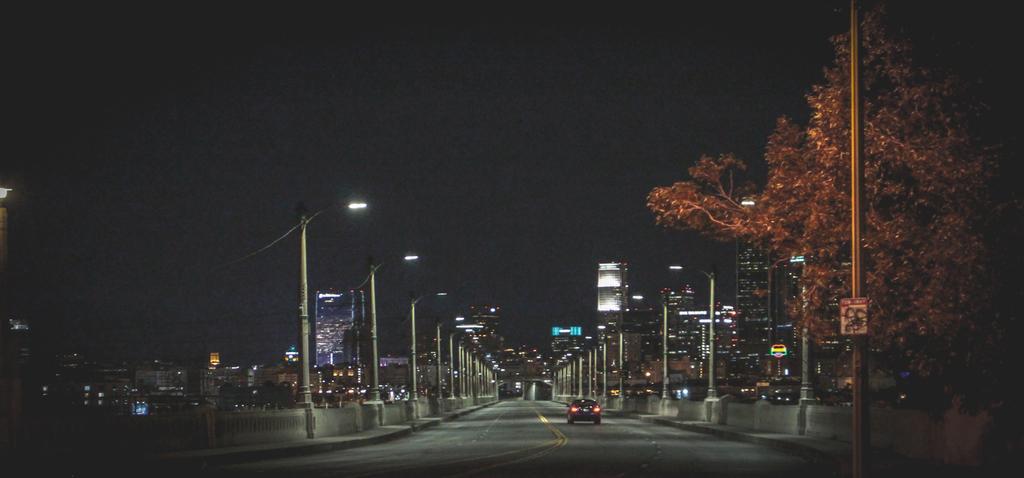Can you describe this image briefly? Vehicle is on the road. Beside this road there are light poles. Far there are a number of buildings. Right side of the image we can see a tree and pole. 